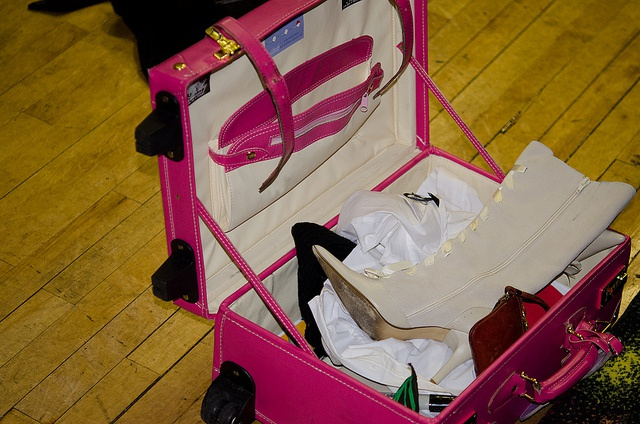Describe the objects in this image and their specific colors. I can see suitcase in olive, darkgray, brown, black, and maroon tones and handbag in olive, black, maroon, and brown tones in this image. 